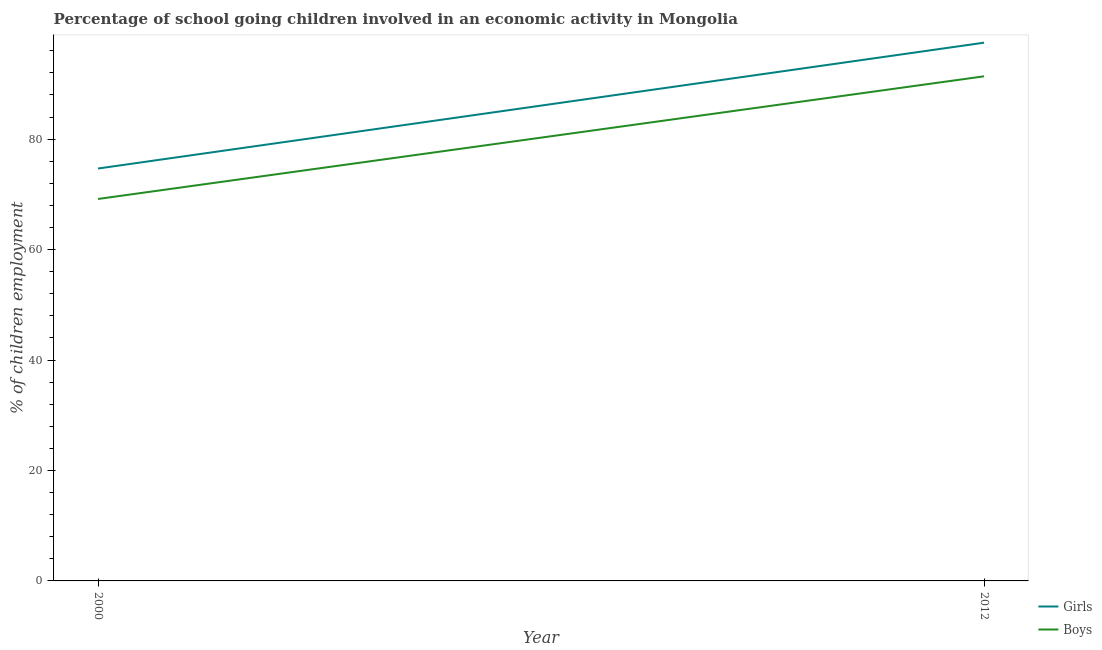Does the line corresponding to percentage of school going girls intersect with the line corresponding to percentage of school going boys?
Make the answer very short. No. Is the number of lines equal to the number of legend labels?
Offer a very short reply. Yes. What is the percentage of school going boys in 2000?
Provide a succinct answer. 69.17. Across all years, what is the maximum percentage of school going boys?
Your response must be concise. 91.38. Across all years, what is the minimum percentage of school going boys?
Your response must be concise. 69.17. In which year was the percentage of school going girls maximum?
Your answer should be compact. 2012. In which year was the percentage of school going girls minimum?
Keep it short and to the point. 2000. What is the total percentage of school going girls in the graph?
Provide a short and direct response. 172.15. What is the difference between the percentage of school going boys in 2000 and that in 2012?
Your response must be concise. -22.21. What is the difference between the percentage of school going girls in 2012 and the percentage of school going boys in 2000?
Provide a succinct answer. 28.3. What is the average percentage of school going girls per year?
Offer a very short reply. 86.07. In the year 2000, what is the difference between the percentage of school going girls and percentage of school going boys?
Make the answer very short. 5.51. In how many years, is the percentage of school going girls greater than 16 %?
Provide a succinct answer. 2. What is the ratio of the percentage of school going girls in 2000 to that in 2012?
Make the answer very short. 0.77. Is the percentage of school going boys in 2000 less than that in 2012?
Provide a short and direct response. Yes. Is the percentage of school going girls strictly less than the percentage of school going boys over the years?
Give a very brief answer. No. How many lines are there?
Provide a short and direct response. 2. Does the graph contain grids?
Offer a terse response. No. How many legend labels are there?
Your response must be concise. 2. How are the legend labels stacked?
Your answer should be compact. Vertical. What is the title of the graph?
Keep it short and to the point. Percentage of school going children involved in an economic activity in Mongolia. Does "Mineral" appear as one of the legend labels in the graph?
Ensure brevity in your answer.  No. What is the label or title of the X-axis?
Offer a terse response. Year. What is the label or title of the Y-axis?
Your answer should be compact. % of children employment. What is the % of children employment in Girls in 2000?
Make the answer very short. 74.68. What is the % of children employment in Boys in 2000?
Give a very brief answer. 69.17. What is the % of children employment in Girls in 2012?
Offer a terse response. 97.47. What is the % of children employment in Boys in 2012?
Offer a terse response. 91.38. Across all years, what is the maximum % of children employment of Girls?
Make the answer very short. 97.47. Across all years, what is the maximum % of children employment of Boys?
Ensure brevity in your answer.  91.38. Across all years, what is the minimum % of children employment of Girls?
Make the answer very short. 74.68. Across all years, what is the minimum % of children employment in Boys?
Your answer should be very brief. 69.17. What is the total % of children employment in Girls in the graph?
Keep it short and to the point. 172.15. What is the total % of children employment of Boys in the graph?
Offer a terse response. 160.55. What is the difference between the % of children employment in Girls in 2000 and that in 2012?
Offer a terse response. -22.79. What is the difference between the % of children employment of Boys in 2000 and that in 2012?
Provide a short and direct response. -22.21. What is the difference between the % of children employment in Girls in 2000 and the % of children employment in Boys in 2012?
Ensure brevity in your answer.  -16.7. What is the average % of children employment of Girls per year?
Provide a succinct answer. 86.08. What is the average % of children employment in Boys per year?
Provide a short and direct response. 80.27. In the year 2000, what is the difference between the % of children employment of Girls and % of children employment of Boys?
Your response must be concise. 5.51. In the year 2012, what is the difference between the % of children employment in Girls and % of children employment in Boys?
Keep it short and to the point. 6.09. What is the ratio of the % of children employment in Girls in 2000 to that in 2012?
Offer a terse response. 0.77. What is the ratio of the % of children employment in Boys in 2000 to that in 2012?
Your response must be concise. 0.76. What is the difference between the highest and the second highest % of children employment of Girls?
Make the answer very short. 22.79. What is the difference between the highest and the second highest % of children employment in Boys?
Provide a short and direct response. 22.21. What is the difference between the highest and the lowest % of children employment of Girls?
Give a very brief answer. 22.79. What is the difference between the highest and the lowest % of children employment in Boys?
Offer a terse response. 22.21. 